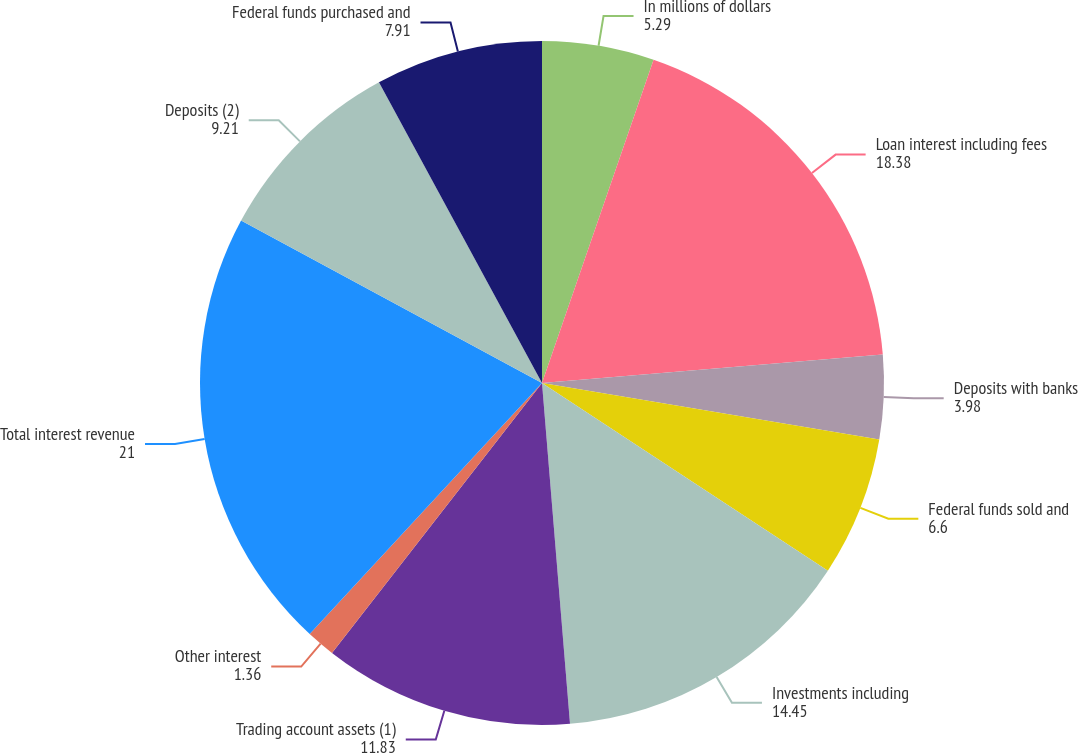Convert chart to OTSL. <chart><loc_0><loc_0><loc_500><loc_500><pie_chart><fcel>In millions of dollars<fcel>Loan interest including fees<fcel>Deposits with banks<fcel>Federal funds sold and<fcel>Investments including<fcel>Trading account assets (1)<fcel>Other interest<fcel>Total interest revenue<fcel>Deposits (2)<fcel>Federal funds purchased and<nl><fcel>5.29%<fcel>18.38%<fcel>3.98%<fcel>6.6%<fcel>14.45%<fcel>11.83%<fcel>1.36%<fcel>21.0%<fcel>9.21%<fcel>7.91%<nl></chart> 